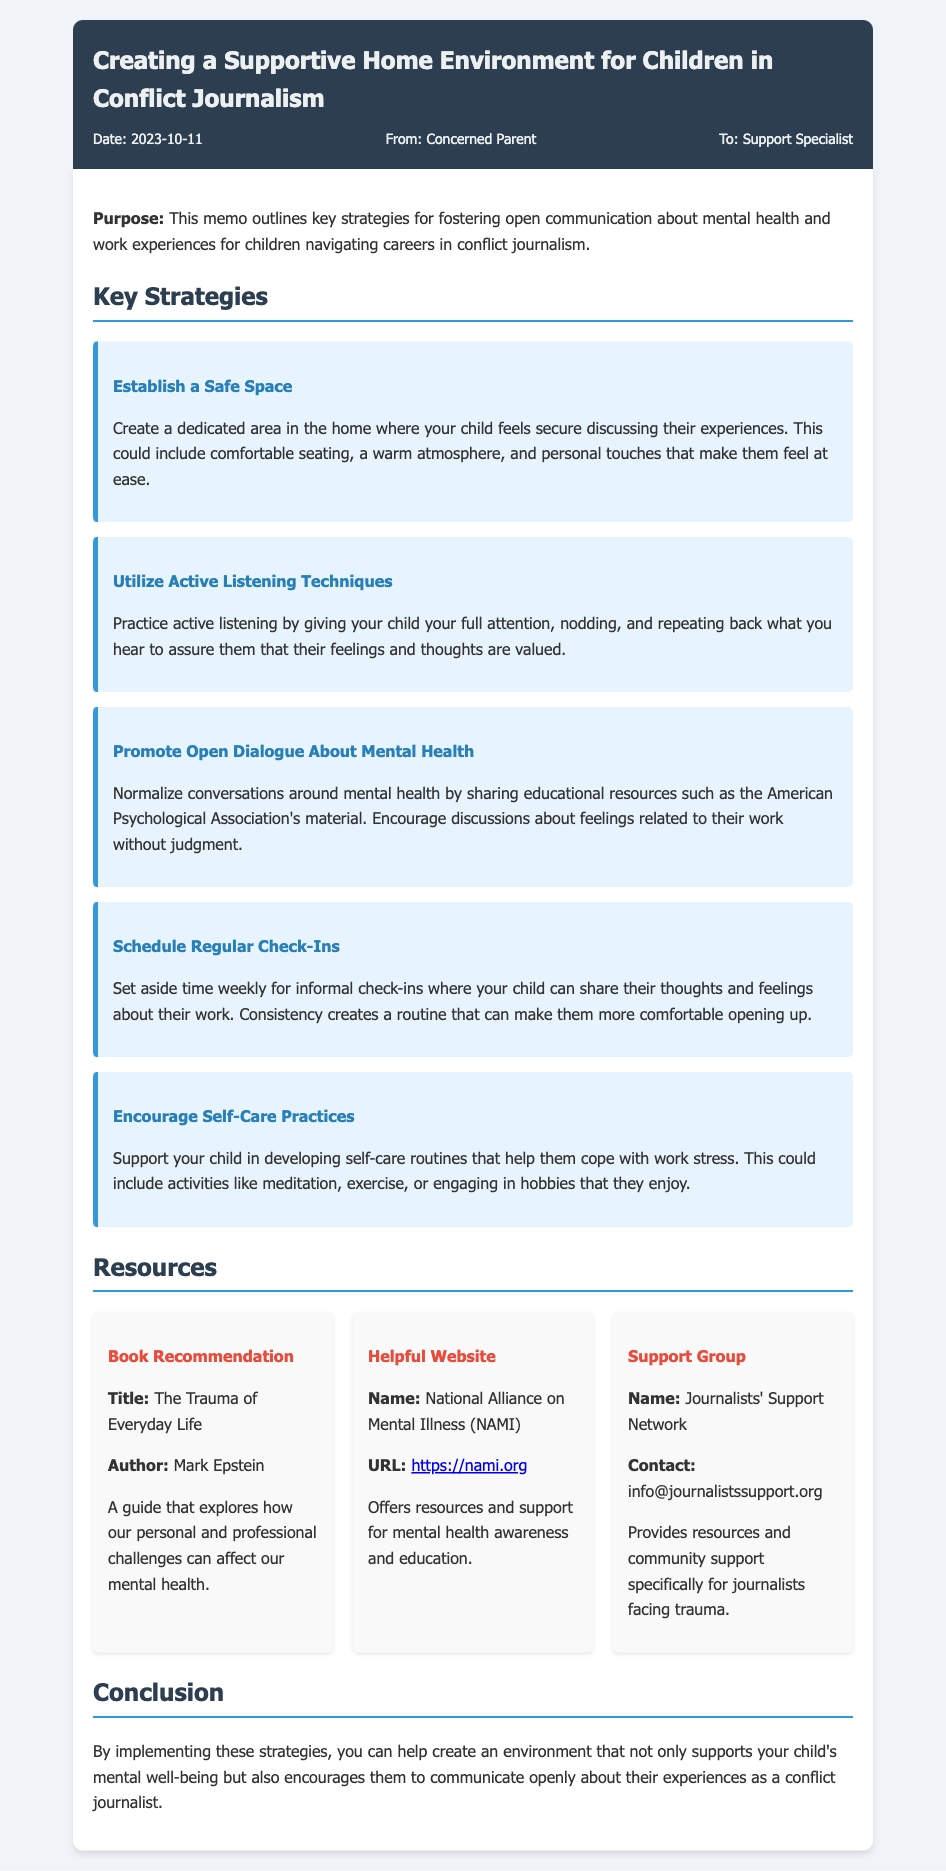What is the date of the memo? The date is mentioned in the memo's header, indicating when it was created.
Answer: 2023-10-11 Who is the author of the memo? The author is specified in the memo's header, showing who wrote it.
Answer: Concerned Parent What is the main purpose of the memo? The purpose is stated at the beginning of the memo, defining its focus.
Answer: Create a supportive home environment for children in conflict journalism What strategy involves creating a secure area for discussion? This strategy is listed among key strategies aimed at fostering communication.
Answer: Establish a Safe Space Which website is recommended for mental health resources? The memo provides a specific website that offers mental health support and resources.
Answer: National Alliance on Mental Illness (NAMI) What is one of the suggested self-care practices? This is included in the strategies to help support a child's mental well-being.
Answer: Meditation How many key strategies are outlined in the memo? The memo lists a total number of strategies aimed at fostering communication and understanding.
Answer: Five What is a recommended book mentioned in the resources? The title of a book that explores mental health challenges is provided in the resources section.
Answer: The Trauma of Everyday Life What is the contact for the Journalists' Support Network? The memo includes contact information for a support group specific to journalists.
Answer: info@journalistssupport.org 